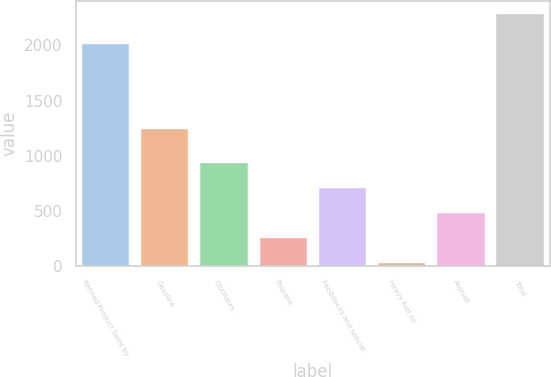Convert chart. <chart><loc_0><loc_0><loc_500><loc_500><bar_chart><fcel>Refined Product Sales by<fcel>Gasoline<fcel>Distillates<fcel>Propane<fcel>Feedstocks and special<fcel>Heavy fuel oil<fcel>Asphalt<fcel>Total<nl><fcel>2015<fcel>1241<fcel>933.6<fcel>255.9<fcel>707.7<fcel>30<fcel>481.8<fcel>2289<nl></chart> 